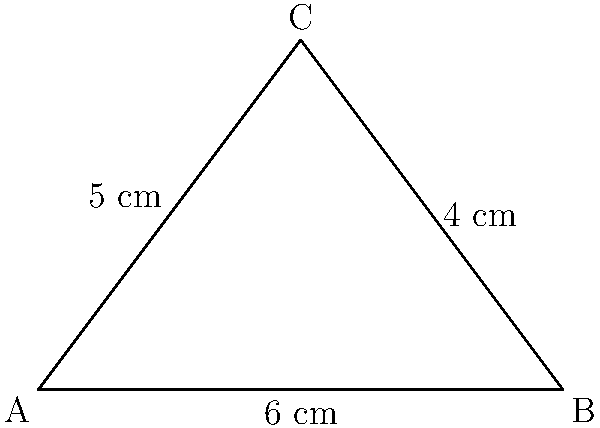A triangular therapeutic cushion for pressure relief has the following dimensions: base of 6 cm, height of 4 cm, and hypotenuse of 5 cm. What is the area of this cushion? To find the area of the triangular cushion, we'll use the formula for the area of a triangle:

$$A = \frac{1}{2} \times base \times height$$

Given:
- Base = 6 cm
- Height = 4 cm

Step 1: Plug the values into the formula
$$A = \frac{1}{2} \times 6 \times 4$$

Step 2: Multiply
$$A = \frac{1}{2} \times 24$$

Step 3: Simplify
$$A = 12$$

Therefore, the area of the triangular therapeutic cushion is 12 square centimeters.

Note: The hypotenuse length (5 cm) is not needed for this calculation but could be used to verify that this is indeed a right-angled triangle using the Pythagorean theorem.
Answer: 12 cm² 